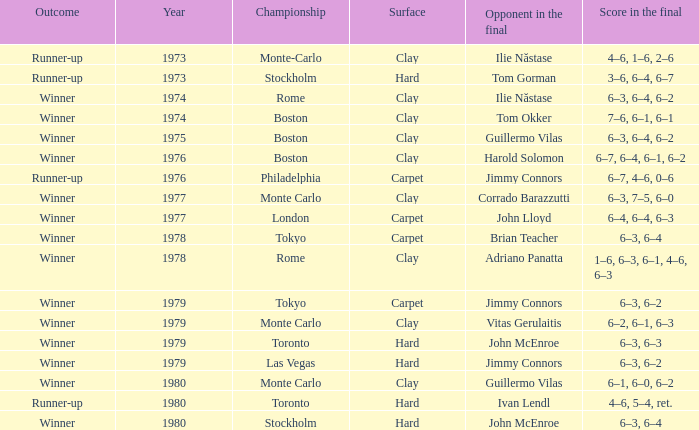Parse the table in full. {'header': ['Outcome', 'Year', 'Championship', 'Surface', 'Opponent in the final', 'Score in the final'], 'rows': [['Runner-up', '1973', 'Monte-Carlo', 'Clay', 'Ilie Năstase', '4–6, 1–6, 2–6'], ['Runner-up', '1973', 'Stockholm', 'Hard', 'Tom Gorman', '3–6, 6–4, 6–7'], ['Winner', '1974', 'Rome', 'Clay', 'Ilie Năstase', '6–3, 6–4, 6–2'], ['Winner', '1974', 'Boston', 'Clay', 'Tom Okker', '7–6, 6–1, 6–1'], ['Winner', '1975', 'Boston', 'Clay', 'Guillermo Vilas', '6–3, 6–4, 6–2'], ['Winner', '1976', 'Boston', 'Clay', 'Harold Solomon', '6–7, 6–4, 6–1, 6–2'], ['Runner-up', '1976', 'Philadelphia', 'Carpet', 'Jimmy Connors', '6–7, 4–6, 0–6'], ['Winner', '1977', 'Monte Carlo', 'Clay', 'Corrado Barazzutti', '6–3, 7–5, 6–0'], ['Winner', '1977', 'London', 'Carpet', 'John Lloyd', '6–4, 6–4, 6–3'], ['Winner', '1978', 'Tokyo', 'Carpet', 'Brian Teacher', '6–3, 6–4'], ['Winner', '1978', 'Rome', 'Clay', 'Adriano Panatta', '1–6, 6–3, 6–1, 4–6, 6–3'], ['Winner', '1979', 'Tokyo', 'Carpet', 'Jimmy Connors', '6–3, 6–2'], ['Winner', '1979', 'Monte Carlo', 'Clay', 'Vitas Gerulaitis', '6–2, 6–1, 6–3'], ['Winner', '1979', 'Toronto', 'Hard', 'John McEnroe', '6–3, 6–3'], ['Winner', '1979', 'Las Vegas', 'Hard', 'Jimmy Connors', '6–3, 6–2'], ['Winner', '1980', 'Monte Carlo', 'Clay', 'Guillermo Vilas', '6–1, 6–0, 6–2'], ['Runner-up', '1980', 'Toronto', 'Hard', 'Ivan Lendl', '4–6, 5–4, ret.'], ['Winner', '1980', 'Stockholm', 'Hard', 'John McEnroe', '6–3, 6–4']]} Name the surface for philadelphia Carpet. 